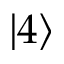<formula> <loc_0><loc_0><loc_500><loc_500>\left | 4 \right ></formula> 